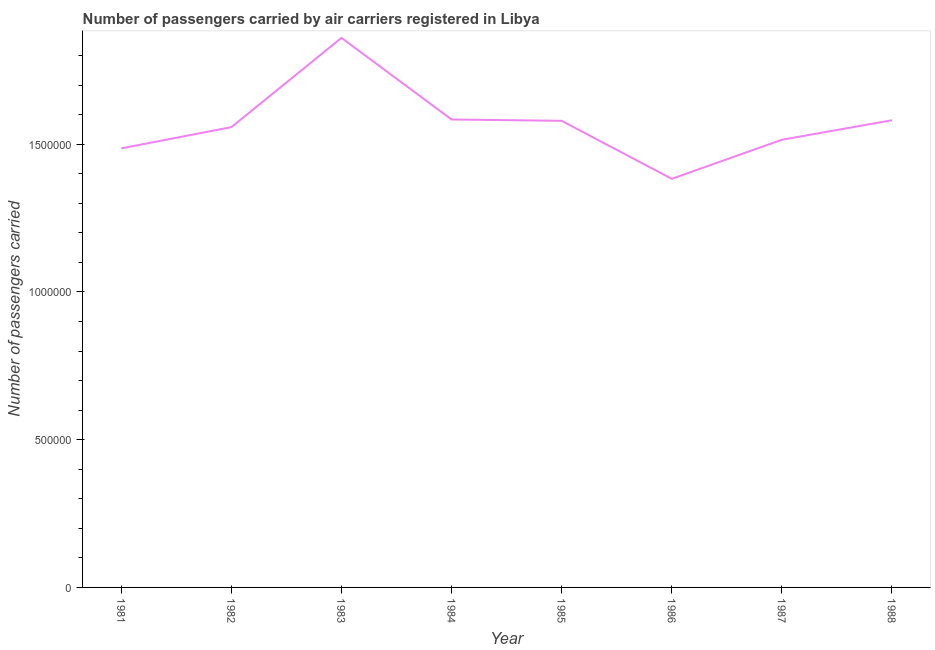What is the number of passengers carried in 1987?
Provide a short and direct response. 1.52e+06. Across all years, what is the maximum number of passengers carried?
Your answer should be compact. 1.86e+06. Across all years, what is the minimum number of passengers carried?
Your response must be concise. 1.38e+06. In which year was the number of passengers carried maximum?
Provide a succinct answer. 1983. What is the sum of the number of passengers carried?
Offer a terse response. 1.25e+07. What is the difference between the number of passengers carried in 1982 and 1984?
Offer a very short reply. -2.60e+04. What is the average number of passengers carried per year?
Keep it short and to the point. 1.57e+06. What is the median number of passengers carried?
Make the answer very short. 1.57e+06. In how many years, is the number of passengers carried greater than 1000000 ?
Your response must be concise. 8. Do a majority of the years between 1982 and 1983 (inclusive) have number of passengers carried greater than 500000 ?
Make the answer very short. Yes. What is the ratio of the number of passengers carried in 1987 to that in 1988?
Ensure brevity in your answer.  0.96. Is the number of passengers carried in 1982 less than that in 1983?
Give a very brief answer. Yes. What is the difference between the highest and the second highest number of passengers carried?
Keep it short and to the point. 2.76e+05. What is the difference between the highest and the lowest number of passengers carried?
Your response must be concise. 4.77e+05. Does the number of passengers carried monotonically increase over the years?
Offer a terse response. No. How many lines are there?
Your answer should be very brief. 1. How many years are there in the graph?
Keep it short and to the point. 8. What is the difference between two consecutive major ticks on the Y-axis?
Ensure brevity in your answer.  5.00e+05. What is the title of the graph?
Make the answer very short. Number of passengers carried by air carriers registered in Libya. What is the label or title of the X-axis?
Provide a succinct answer. Year. What is the label or title of the Y-axis?
Give a very brief answer. Number of passengers carried. What is the Number of passengers carried of 1981?
Keep it short and to the point. 1.49e+06. What is the Number of passengers carried in 1982?
Your answer should be compact. 1.56e+06. What is the Number of passengers carried in 1983?
Your answer should be compact. 1.86e+06. What is the Number of passengers carried in 1984?
Keep it short and to the point. 1.58e+06. What is the Number of passengers carried of 1985?
Offer a terse response. 1.58e+06. What is the Number of passengers carried of 1986?
Keep it short and to the point. 1.38e+06. What is the Number of passengers carried of 1987?
Provide a succinct answer. 1.52e+06. What is the Number of passengers carried of 1988?
Your answer should be compact. 1.58e+06. What is the difference between the Number of passengers carried in 1981 and 1982?
Your answer should be compact. -7.18e+04. What is the difference between the Number of passengers carried in 1981 and 1983?
Your answer should be compact. -3.74e+05. What is the difference between the Number of passengers carried in 1981 and 1984?
Offer a very short reply. -9.78e+04. What is the difference between the Number of passengers carried in 1981 and 1985?
Offer a very short reply. -9.33e+04. What is the difference between the Number of passengers carried in 1981 and 1986?
Your answer should be compact. 1.03e+05. What is the difference between the Number of passengers carried in 1981 and 1987?
Your answer should be compact. -2.91e+04. What is the difference between the Number of passengers carried in 1981 and 1988?
Ensure brevity in your answer.  -9.52e+04. What is the difference between the Number of passengers carried in 1982 and 1983?
Provide a short and direct response. -3.02e+05. What is the difference between the Number of passengers carried in 1982 and 1984?
Keep it short and to the point. -2.60e+04. What is the difference between the Number of passengers carried in 1982 and 1985?
Your response must be concise. -2.15e+04. What is the difference between the Number of passengers carried in 1982 and 1986?
Your response must be concise. 1.75e+05. What is the difference between the Number of passengers carried in 1982 and 1987?
Provide a short and direct response. 4.27e+04. What is the difference between the Number of passengers carried in 1982 and 1988?
Offer a terse response. -2.34e+04. What is the difference between the Number of passengers carried in 1983 and 1984?
Provide a short and direct response. 2.76e+05. What is the difference between the Number of passengers carried in 1983 and 1985?
Make the answer very short. 2.81e+05. What is the difference between the Number of passengers carried in 1983 and 1986?
Provide a succinct answer. 4.77e+05. What is the difference between the Number of passengers carried in 1983 and 1987?
Make the answer very short. 3.45e+05. What is the difference between the Number of passengers carried in 1983 and 1988?
Your answer should be compact. 2.79e+05. What is the difference between the Number of passengers carried in 1984 and 1985?
Your answer should be compact. 4500. What is the difference between the Number of passengers carried in 1984 and 1986?
Offer a very short reply. 2.01e+05. What is the difference between the Number of passengers carried in 1984 and 1987?
Ensure brevity in your answer.  6.87e+04. What is the difference between the Number of passengers carried in 1984 and 1988?
Give a very brief answer. 2600. What is the difference between the Number of passengers carried in 1985 and 1986?
Offer a very short reply. 1.96e+05. What is the difference between the Number of passengers carried in 1985 and 1987?
Make the answer very short. 6.42e+04. What is the difference between the Number of passengers carried in 1985 and 1988?
Your answer should be very brief. -1900. What is the difference between the Number of passengers carried in 1986 and 1987?
Keep it short and to the point. -1.32e+05. What is the difference between the Number of passengers carried in 1986 and 1988?
Provide a succinct answer. -1.98e+05. What is the difference between the Number of passengers carried in 1987 and 1988?
Provide a succinct answer. -6.61e+04. What is the ratio of the Number of passengers carried in 1981 to that in 1982?
Make the answer very short. 0.95. What is the ratio of the Number of passengers carried in 1981 to that in 1983?
Ensure brevity in your answer.  0.8. What is the ratio of the Number of passengers carried in 1981 to that in 1984?
Your answer should be compact. 0.94. What is the ratio of the Number of passengers carried in 1981 to that in 1985?
Give a very brief answer. 0.94. What is the ratio of the Number of passengers carried in 1981 to that in 1986?
Keep it short and to the point. 1.07. What is the ratio of the Number of passengers carried in 1981 to that in 1987?
Your answer should be compact. 0.98. What is the ratio of the Number of passengers carried in 1981 to that in 1988?
Your answer should be very brief. 0.94. What is the ratio of the Number of passengers carried in 1982 to that in 1983?
Offer a very short reply. 0.84. What is the ratio of the Number of passengers carried in 1982 to that in 1984?
Provide a succinct answer. 0.98. What is the ratio of the Number of passengers carried in 1982 to that in 1986?
Make the answer very short. 1.13. What is the ratio of the Number of passengers carried in 1982 to that in 1987?
Make the answer very short. 1.03. What is the ratio of the Number of passengers carried in 1983 to that in 1984?
Offer a terse response. 1.17. What is the ratio of the Number of passengers carried in 1983 to that in 1985?
Provide a short and direct response. 1.18. What is the ratio of the Number of passengers carried in 1983 to that in 1986?
Your answer should be compact. 1.34. What is the ratio of the Number of passengers carried in 1983 to that in 1987?
Your response must be concise. 1.23. What is the ratio of the Number of passengers carried in 1983 to that in 1988?
Make the answer very short. 1.18. What is the ratio of the Number of passengers carried in 1984 to that in 1986?
Your answer should be compact. 1.15. What is the ratio of the Number of passengers carried in 1984 to that in 1987?
Provide a short and direct response. 1.04. What is the ratio of the Number of passengers carried in 1985 to that in 1986?
Offer a very short reply. 1.14. What is the ratio of the Number of passengers carried in 1985 to that in 1987?
Give a very brief answer. 1.04. What is the ratio of the Number of passengers carried in 1985 to that in 1988?
Your response must be concise. 1. What is the ratio of the Number of passengers carried in 1986 to that in 1988?
Keep it short and to the point. 0.88. What is the ratio of the Number of passengers carried in 1987 to that in 1988?
Ensure brevity in your answer.  0.96. 